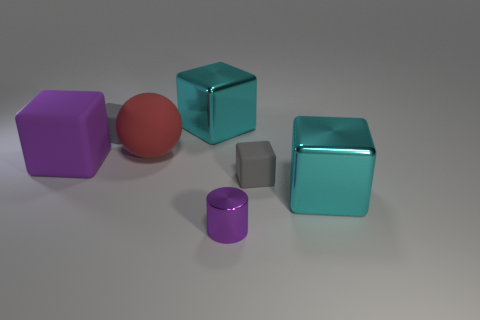Are the shadows being cast by the objects consistent with a single light source? Yes, the shadows suggest there is a single light source in the scene. The direction and length of the shadows provide cues about the angle and distance of the light relative to the objects. 